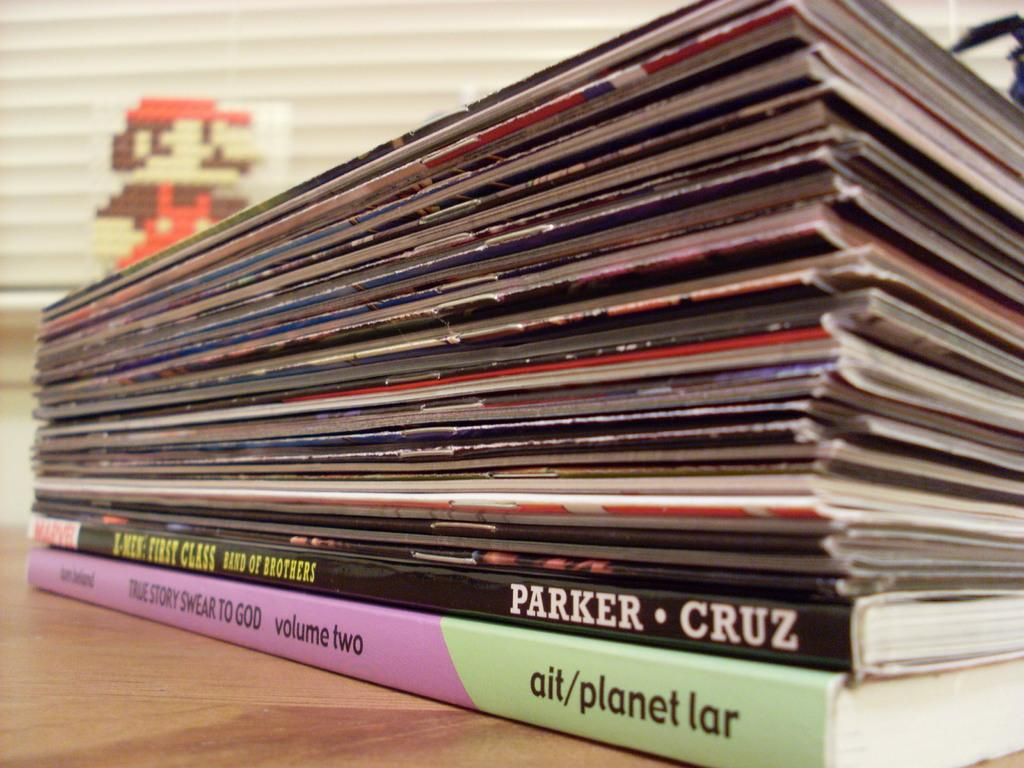<image>
Render a clear and concise summary of the photo. A stack of magazines, with one being written by Parker and Cruz. 